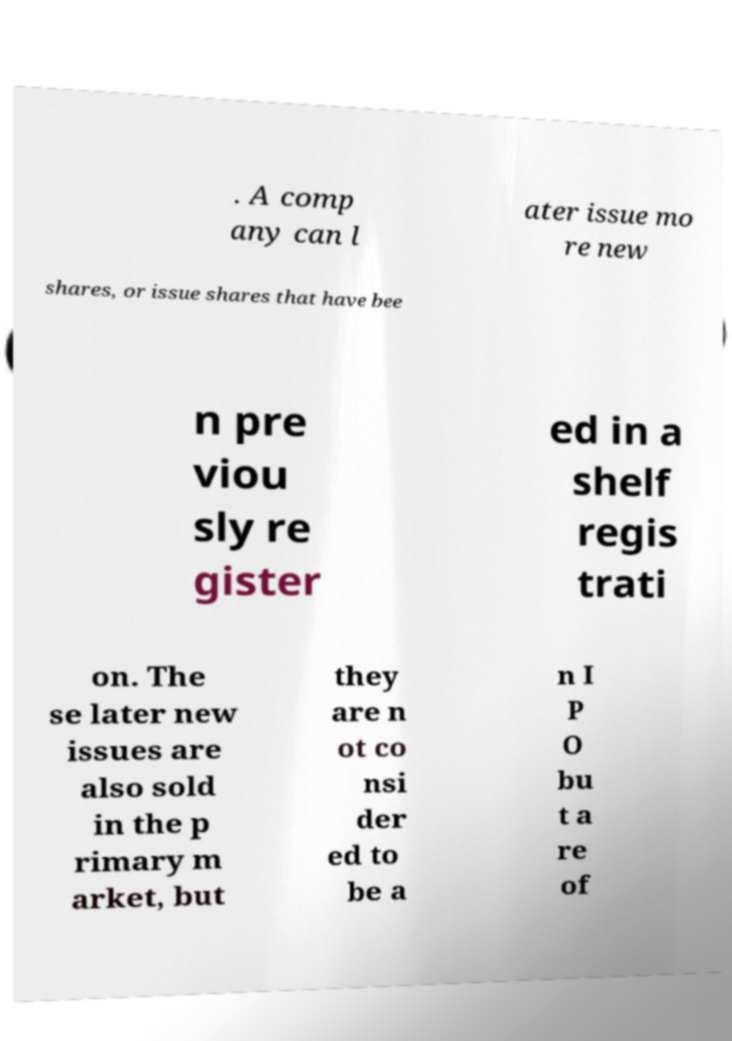Can you accurately transcribe the text from the provided image for me? . A comp any can l ater issue mo re new shares, or issue shares that have bee n pre viou sly re gister ed in a shelf regis trati on. The se later new issues are also sold in the p rimary m arket, but they are n ot co nsi der ed to be a n I P O bu t a re of 